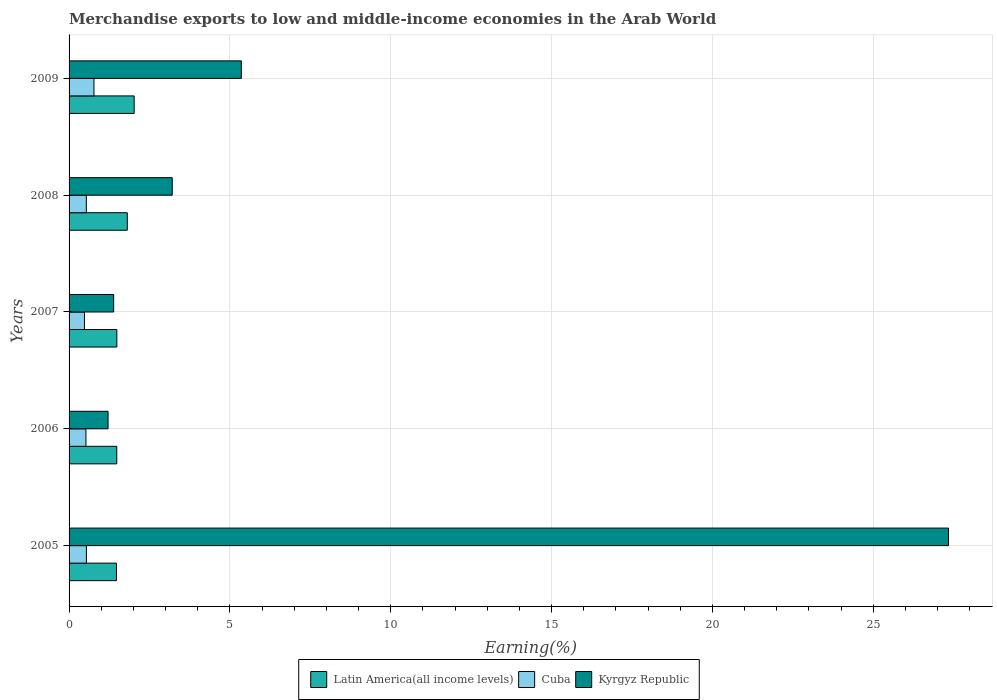How many different coloured bars are there?
Your answer should be compact. 3. Are the number of bars per tick equal to the number of legend labels?
Your response must be concise. Yes. How many bars are there on the 4th tick from the top?
Offer a very short reply. 3. How many bars are there on the 5th tick from the bottom?
Provide a short and direct response. 3. What is the percentage of amount earned from merchandise exports in Cuba in 2009?
Ensure brevity in your answer.  0.77. Across all years, what is the maximum percentage of amount earned from merchandise exports in Kyrgyz Republic?
Provide a succinct answer. 27.34. Across all years, what is the minimum percentage of amount earned from merchandise exports in Kyrgyz Republic?
Ensure brevity in your answer.  1.21. In which year was the percentage of amount earned from merchandise exports in Cuba maximum?
Your answer should be very brief. 2009. What is the total percentage of amount earned from merchandise exports in Cuba in the graph?
Keep it short and to the point. 2.85. What is the difference between the percentage of amount earned from merchandise exports in Cuba in 2008 and that in 2009?
Make the answer very short. -0.24. What is the difference between the percentage of amount earned from merchandise exports in Kyrgyz Republic in 2005 and the percentage of amount earned from merchandise exports in Latin America(all income levels) in 2009?
Provide a succinct answer. 25.31. What is the average percentage of amount earned from merchandise exports in Latin America(all income levels) per year?
Offer a terse response. 1.65. In the year 2006, what is the difference between the percentage of amount earned from merchandise exports in Kyrgyz Republic and percentage of amount earned from merchandise exports in Latin America(all income levels)?
Give a very brief answer. -0.27. What is the ratio of the percentage of amount earned from merchandise exports in Cuba in 2006 to that in 2009?
Offer a terse response. 0.68. Is the percentage of amount earned from merchandise exports in Cuba in 2006 less than that in 2009?
Offer a terse response. Yes. Is the difference between the percentage of amount earned from merchandise exports in Kyrgyz Republic in 2006 and 2008 greater than the difference between the percentage of amount earned from merchandise exports in Latin America(all income levels) in 2006 and 2008?
Your response must be concise. No. What is the difference between the highest and the second highest percentage of amount earned from merchandise exports in Cuba?
Provide a succinct answer. 0.23. What is the difference between the highest and the lowest percentage of amount earned from merchandise exports in Kyrgyz Republic?
Offer a terse response. 26.13. In how many years, is the percentage of amount earned from merchandise exports in Kyrgyz Republic greater than the average percentage of amount earned from merchandise exports in Kyrgyz Republic taken over all years?
Provide a succinct answer. 1. Is the sum of the percentage of amount earned from merchandise exports in Kyrgyz Republic in 2006 and 2007 greater than the maximum percentage of amount earned from merchandise exports in Cuba across all years?
Keep it short and to the point. Yes. What does the 2nd bar from the top in 2008 represents?
Offer a very short reply. Cuba. What does the 1st bar from the bottom in 2009 represents?
Your answer should be compact. Latin America(all income levels). Is it the case that in every year, the sum of the percentage of amount earned from merchandise exports in Cuba and percentage of amount earned from merchandise exports in Latin America(all income levels) is greater than the percentage of amount earned from merchandise exports in Kyrgyz Republic?
Provide a succinct answer. No. How many bars are there?
Provide a short and direct response. 15. How many years are there in the graph?
Give a very brief answer. 5. What is the difference between two consecutive major ticks on the X-axis?
Ensure brevity in your answer.  5. Does the graph contain any zero values?
Provide a short and direct response. No. Where does the legend appear in the graph?
Offer a very short reply. Bottom center. How many legend labels are there?
Ensure brevity in your answer.  3. What is the title of the graph?
Give a very brief answer. Merchandise exports to low and middle-income economies in the Arab World. Does "Guam" appear as one of the legend labels in the graph?
Your answer should be very brief. No. What is the label or title of the X-axis?
Provide a short and direct response. Earning(%). What is the Earning(%) in Latin America(all income levels) in 2005?
Your response must be concise. 1.47. What is the Earning(%) in Cuba in 2005?
Provide a succinct answer. 0.54. What is the Earning(%) of Kyrgyz Republic in 2005?
Offer a very short reply. 27.34. What is the Earning(%) of Latin America(all income levels) in 2006?
Your answer should be compact. 1.48. What is the Earning(%) in Cuba in 2006?
Your answer should be very brief. 0.52. What is the Earning(%) in Kyrgyz Republic in 2006?
Make the answer very short. 1.21. What is the Earning(%) of Latin America(all income levels) in 2007?
Provide a short and direct response. 1.49. What is the Earning(%) in Cuba in 2007?
Your response must be concise. 0.48. What is the Earning(%) in Kyrgyz Republic in 2007?
Offer a terse response. 1.39. What is the Earning(%) of Latin America(all income levels) in 2008?
Offer a very short reply. 1.81. What is the Earning(%) in Cuba in 2008?
Offer a terse response. 0.54. What is the Earning(%) of Kyrgyz Republic in 2008?
Offer a terse response. 3.21. What is the Earning(%) in Latin America(all income levels) in 2009?
Your response must be concise. 2.02. What is the Earning(%) in Cuba in 2009?
Your answer should be very brief. 0.77. What is the Earning(%) of Kyrgyz Republic in 2009?
Offer a terse response. 5.35. Across all years, what is the maximum Earning(%) in Latin America(all income levels)?
Provide a short and direct response. 2.02. Across all years, what is the maximum Earning(%) of Cuba?
Your answer should be compact. 0.77. Across all years, what is the maximum Earning(%) in Kyrgyz Republic?
Provide a succinct answer. 27.34. Across all years, what is the minimum Earning(%) of Latin America(all income levels)?
Ensure brevity in your answer.  1.47. Across all years, what is the minimum Earning(%) of Cuba?
Provide a succinct answer. 0.48. Across all years, what is the minimum Earning(%) in Kyrgyz Republic?
Your answer should be very brief. 1.21. What is the total Earning(%) of Latin America(all income levels) in the graph?
Your answer should be very brief. 8.27. What is the total Earning(%) of Cuba in the graph?
Give a very brief answer. 2.85. What is the total Earning(%) of Kyrgyz Republic in the graph?
Ensure brevity in your answer.  38.5. What is the difference between the Earning(%) in Latin America(all income levels) in 2005 and that in 2006?
Make the answer very short. -0.01. What is the difference between the Earning(%) in Cuba in 2005 and that in 2006?
Make the answer very short. 0.01. What is the difference between the Earning(%) of Kyrgyz Republic in 2005 and that in 2006?
Provide a short and direct response. 26.13. What is the difference between the Earning(%) in Latin America(all income levels) in 2005 and that in 2007?
Offer a terse response. -0.01. What is the difference between the Earning(%) of Cuba in 2005 and that in 2007?
Keep it short and to the point. 0.06. What is the difference between the Earning(%) of Kyrgyz Republic in 2005 and that in 2007?
Offer a terse response. 25.95. What is the difference between the Earning(%) in Latin America(all income levels) in 2005 and that in 2008?
Provide a succinct answer. -0.34. What is the difference between the Earning(%) of Cuba in 2005 and that in 2008?
Provide a short and direct response. 0. What is the difference between the Earning(%) in Kyrgyz Republic in 2005 and that in 2008?
Offer a terse response. 24.13. What is the difference between the Earning(%) of Latin America(all income levels) in 2005 and that in 2009?
Your response must be concise. -0.55. What is the difference between the Earning(%) of Cuba in 2005 and that in 2009?
Provide a succinct answer. -0.23. What is the difference between the Earning(%) in Kyrgyz Republic in 2005 and that in 2009?
Make the answer very short. 21.98. What is the difference between the Earning(%) in Latin America(all income levels) in 2006 and that in 2007?
Ensure brevity in your answer.  -0. What is the difference between the Earning(%) of Cuba in 2006 and that in 2007?
Your answer should be very brief. 0.05. What is the difference between the Earning(%) in Kyrgyz Republic in 2006 and that in 2007?
Offer a terse response. -0.17. What is the difference between the Earning(%) in Latin America(all income levels) in 2006 and that in 2008?
Your response must be concise. -0.33. What is the difference between the Earning(%) of Cuba in 2006 and that in 2008?
Your response must be concise. -0.01. What is the difference between the Earning(%) of Kyrgyz Republic in 2006 and that in 2008?
Offer a terse response. -1.99. What is the difference between the Earning(%) of Latin America(all income levels) in 2006 and that in 2009?
Give a very brief answer. -0.54. What is the difference between the Earning(%) in Cuba in 2006 and that in 2009?
Make the answer very short. -0.25. What is the difference between the Earning(%) in Kyrgyz Republic in 2006 and that in 2009?
Your answer should be very brief. -4.14. What is the difference between the Earning(%) in Latin America(all income levels) in 2007 and that in 2008?
Give a very brief answer. -0.32. What is the difference between the Earning(%) of Cuba in 2007 and that in 2008?
Your answer should be compact. -0.06. What is the difference between the Earning(%) in Kyrgyz Republic in 2007 and that in 2008?
Your response must be concise. -1.82. What is the difference between the Earning(%) in Latin America(all income levels) in 2007 and that in 2009?
Give a very brief answer. -0.54. What is the difference between the Earning(%) of Cuba in 2007 and that in 2009?
Make the answer very short. -0.29. What is the difference between the Earning(%) in Kyrgyz Republic in 2007 and that in 2009?
Make the answer very short. -3.97. What is the difference between the Earning(%) in Latin America(all income levels) in 2008 and that in 2009?
Ensure brevity in your answer.  -0.21. What is the difference between the Earning(%) in Cuba in 2008 and that in 2009?
Your answer should be compact. -0.24. What is the difference between the Earning(%) in Kyrgyz Republic in 2008 and that in 2009?
Keep it short and to the point. -2.15. What is the difference between the Earning(%) of Latin America(all income levels) in 2005 and the Earning(%) of Cuba in 2006?
Keep it short and to the point. 0.95. What is the difference between the Earning(%) of Latin America(all income levels) in 2005 and the Earning(%) of Kyrgyz Republic in 2006?
Keep it short and to the point. 0.26. What is the difference between the Earning(%) of Cuba in 2005 and the Earning(%) of Kyrgyz Republic in 2006?
Offer a very short reply. -0.67. What is the difference between the Earning(%) of Latin America(all income levels) in 2005 and the Earning(%) of Cuba in 2007?
Keep it short and to the point. 0.99. What is the difference between the Earning(%) in Latin America(all income levels) in 2005 and the Earning(%) in Kyrgyz Republic in 2007?
Your response must be concise. 0.09. What is the difference between the Earning(%) of Cuba in 2005 and the Earning(%) of Kyrgyz Republic in 2007?
Your response must be concise. -0.85. What is the difference between the Earning(%) of Latin America(all income levels) in 2005 and the Earning(%) of Cuba in 2008?
Keep it short and to the point. 0.94. What is the difference between the Earning(%) in Latin America(all income levels) in 2005 and the Earning(%) in Kyrgyz Republic in 2008?
Your answer should be very brief. -1.73. What is the difference between the Earning(%) in Cuba in 2005 and the Earning(%) in Kyrgyz Republic in 2008?
Your answer should be compact. -2.67. What is the difference between the Earning(%) of Latin America(all income levels) in 2005 and the Earning(%) of Cuba in 2009?
Your response must be concise. 0.7. What is the difference between the Earning(%) of Latin America(all income levels) in 2005 and the Earning(%) of Kyrgyz Republic in 2009?
Offer a very short reply. -3.88. What is the difference between the Earning(%) in Cuba in 2005 and the Earning(%) in Kyrgyz Republic in 2009?
Your answer should be compact. -4.82. What is the difference between the Earning(%) in Latin America(all income levels) in 2006 and the Earning(%) in Cuba in 2007?
Your answer should be compact. 1. What is the difference between the Earning(%) of Latin America(all income levels) in 2006 and the Earning(%) of Kyrgyz Republic in 2007?
Offer a terse response. 0.1. What is the difference between the Earning(%) of Cuba in 2006 and the Earning(%) of Kyrgyz Republic in 2007?
Offer a terse response. -0.86. What is the difference between the Earning(%) of Latin America(all income levels) in 2006 and the Earning(%) of Cuba in 2008?
Offer a terse response. 0.95. What is the difference between the Earning(%) of Latin America(all income levels) in 2006 and the Earning(%) of Kyrgyz Republic in 2008?
Provide a short and direct response. -1.72. What is the difference between the Earning(%) of Cuba in 2006 and the Earning(%) of Kyrgyz Republic in 2008?
Your answer should be compact. -2.68. What is the difference between the Earning(%) of Latin America(all income levels) in 2006 and the Earning(%) of Cuba in 2009?
Your answer should be very brief. 0.71. What is the difference between the Earning(%) in Latin America(all income levels) in 2006 and the Earning(%) in Kyrgyz Republic in 2009?
Your answer should be very brief. -3.87. What is the difference between the Earning(%) in Cuba in 2006 and the Earning(%) in Kyrgyz Republic in 2009?
Your answer should be compact. -4.83. What is the difference between the Earning(%) of Latin America(all income levels) in 2007 and the Earning(%) of Cuba in 2008?
Your answer should be compact. 0.95. What is the difference between the Earning(%) of Latin America(all income levels) in 2007 and the Earning(%) of Kyrgyz Republic in 2008?
Your answer should be very brief. -1.72. What is the difference between the Earning(%) of Cuba in 2007 and the Earning(%) of Kyrgyz Republic in 2008?
Give a very brief answer. -2.73. What is the difference between the Earning(%) of Latin America(all income levels) in 2007 and the Earning(%) of Cuba in 2009?
Your answer should be very brief. 0.71. What is the difference between the Earning(%) in Latin America(all income levels) in 2007 and the Earning(%) in Kyrgyz Republic in 2009?
Ensure brevity in your answer.  -3.87. What is the difference between the Earning(%) in Cuba in 2007 and the Earning(%) in Kyrgyz Republic in 2009?
Offer a very short reply. -4.88. What is the difference between the Earning(%) of Latin America(all income levels) in 2008 and the Earning(%) of Cuba in 2009?
Your answer should be very brief. 1.04. What is the difference between the Earning(%) of Latin America(all income levels) in 2008 and the Earning(%) of Kyrgyz Republic in 2009?
Offer a terse response. -3.54. What is the difference between the Earning(%) in Cuba in 2008 and the Earning(%) in Kyrgyz Republic in 2009?
Make the answer very short. -4.82. What is the average Earning(%) in Latin America(all income levels) per year?
Your answer should be compact. 1.65. What is the average Earning(%) of Cuba per year?
Keep it short and to the point. 0.57. What is the average Earning(%) of Kyrgyz Republic per year?
Provide a succinct answer. 7.7. In the year 2005, what is the difference between the Earning(%) of Latin America(all income levels) and Earning(%) of Cuba?
Provide a succinct answer. 0.93. In the year 2005, what is the difference between the Earning(%) of Latin America(all income levels) and Earning(%) of Kyrgyz Republic?
Ensure brevity in your answer.  -25.87. In the year 2005, what is the difference between the Earning(%) in Cuba and Earning(%) in Kyrgyz Republic?
Give a very brief answer. -26.8. In the year 2006, what is the difference between the Earning(%) of Latin America(all income levels) and Earning(%) of Cuba?
Keep it short and to the point. 0.96. In the year 2006, what is the difference between the Earning(%) in Latin America(all income levels) and Earning(%) in Kyrgyz Republic?
Your answer should be compact. 0.27. In the year 2006, what is the difference between the Earning(%) of Cuba and Earning(%) of Kyrgyz Republic?
Your answer should be compact. -0.69. In the year 2007, what is the difference between the Earning(%) of Latin America(all income levels) and Earning(%) of Kyrgyz Republic?
Ensure brevity in your answer.  0.1. In the year 2007, what is the difference between the Earning(%) in Cuba and Earning(%) in Kyrgyz Republic?
Your response must be concise. -0.91. In the year 2008, what is the difference between the Earning(%) of Latin America(all income levels) and Earning(%) of Cuba?
Give a very brief answer. 1.27. In the year 2008, what is the difference between the Earning(%) of Latin America(all income levels) and Earning(%) of Kyrgyz Republic?
Keep it short and to the point. -1.4. In the year 2008, what is the difference between the Earning(%) in Cuba and Earning(%) in Kyrgyz Republic?
Provide a succinct answer. -2.67. In the year 2009, what is the difference between the Earning(%) of Latin America(all income levels) and Earning(%) of Cuba?
Offer a terse response. 1.25. In the year 2009, what is the difference between the Earning(%) in Latin America(all income levels) and Earning(%) in Kyrgyz Republic?
Give a very brief answer. -3.33. In the year 2009, what is the difference between the Earning(%) in Cuba and Earning(%) in Kyrgyz Republic?
Give a very brief answer. -4.58. What is the ratio of the Earning(%) of Latin America(all income levels) in 2005 to that in 2006?
Your response must be concise. 0.99. What is the ratio of the Earning(%) of Cuba in 2005 to that in 2006?
Give a very brief answer. 1.03. What is the ratio of the Earning(%) of Kyrgyz Republic in 2005 to that in 2006?
Your answer should be very brief. 22.55. What is the ratio of the Earning(%) in Latin America(all income levels) in 2005 to that in 2007?
Make the answer very short. 0.99. What is the ratio of the Earning(%) of Cuba in 2005 to that in 2007?
Provide a short and direct response. 1.12. What is the ratio of the Earning(%) in Kyrgyz Republic in 2005 to that in 2007?
Your response must be concise. 19.73. What is the ratio of the Earning(%) of Latin America(all income levels) in 2005 to that in 2008?
Give a very brief answer. 0.81. What is the ratio of the Earning(%) of Kyrgyz Republic in 2005 to that in 2008?
Your answer should be compact. 8.52. What is the ratio of the Earning(%) of Latin America(all income levels) in 2005 to that in 2009?
Provide a succinct answer. 0.73. What is the ratio of the Earning(%) in Cuba in 2005 to that in 2009?
Give a very brief answer. 0.7. What is the ratio of the Earning(%) in Kyrgyz Republic in 2005 to that in 2009?
Keep it short and to the point. 5.11. What is the ratio of the Earning(%) of Cuba in 2006 to that in 2007?
Keep it short and to the point. 1.09. What is the ratio of the Earning(%) in Kyrgyz Republic in 2006 to that in 2007?
Make the answer very short. 0.87. What is the ratio of the Earning(%) in Latin America(all income levels) in 2006 to that in 2008?
Give a very brief answer. 0.82. What is the ratio of the Earning(%) in Cuba in 2006 to that in 2008?
Provide a short and direct response. 0.98. What is the ratio of the Earning(%) of Kyrgyz Republic in 2006 to that in 2008?
Your response must be concise. 0.38. What is the ratio of the Earning(%) in Latin America(all income levels) in 2006 to that in 2009?
Your answer should be compact. 0.73. What is the ratio of the Earning(%) of Cuba in 2006 to that in 2009?
Your answer should be compact. 0.68. What is the ratio of the Earning(%) in Kyrgyz Republic in 2006 to that in 2009?
Ensure brevity in your answer.  0.23. What is the ratio of the Earning(%) of Latin America(all income levels) in 2007 to that in 2008?
Your answer should be very brief. 0.82. What is the ratio of the Earning(%) of Cuba in 2007 to that in 2008?
Make the answer very short. 0.89. What is the ratio of the Earning(%) of Kyrgyz Republic in 2007 to that in 2008?
Your response must be concise. 0.43. What is the ratio of the Earning(%) of Latin America(all income levels) in 2007 to that in 2009?
Offer a terse response. 0.73. What is the ratio of the Earning(%) in Cuba in 2007 to that in 2009?
Provide a succinct answer. 0.62. What is the ratio of the Earning(%) of Kyrgyz Republic in 2007 to that in 2009?
Keep it short and to the point. 0.26. What is the ratio of the Earning(%) of Latin America(all income levels) in 2008 to that in 2009?
Keep it short and to the point. 0.89. What is the ratio of the Earning(%) of Cuba in 2008 to that in 2009?
Your answer should be very brief. 0.69. What is the ratio of the Earning(%) in Kyrgyz Republic in 2008 to that in 2009?
Make the answer very short. 0.6. What is the difference between the highest and the second highest Earning(%) in Latin America(all income levels)?
Offer a terse response. 0.21. What is the difference between the highest and the second highest Earning(%) of Cuba?
Make the answer very short. 0.23. What is the difference between the highest and the second highest Earning(%) of Kyrgyz Republic?
Provide a short and direct response. 21.98. What is the difference between the highest and the lowest Earning(%) of Latin America(all income levels)?
Provide a succinct answer. 0.55. What is the difference between the highest and the lowest Earning(%) of Cuba?
Provide a succinct answer. 0.29. What is the difference between the highest and the lowest Earning(%) of Kyrgyz Republic?
Ensure brevity in your answer.  26.13. 